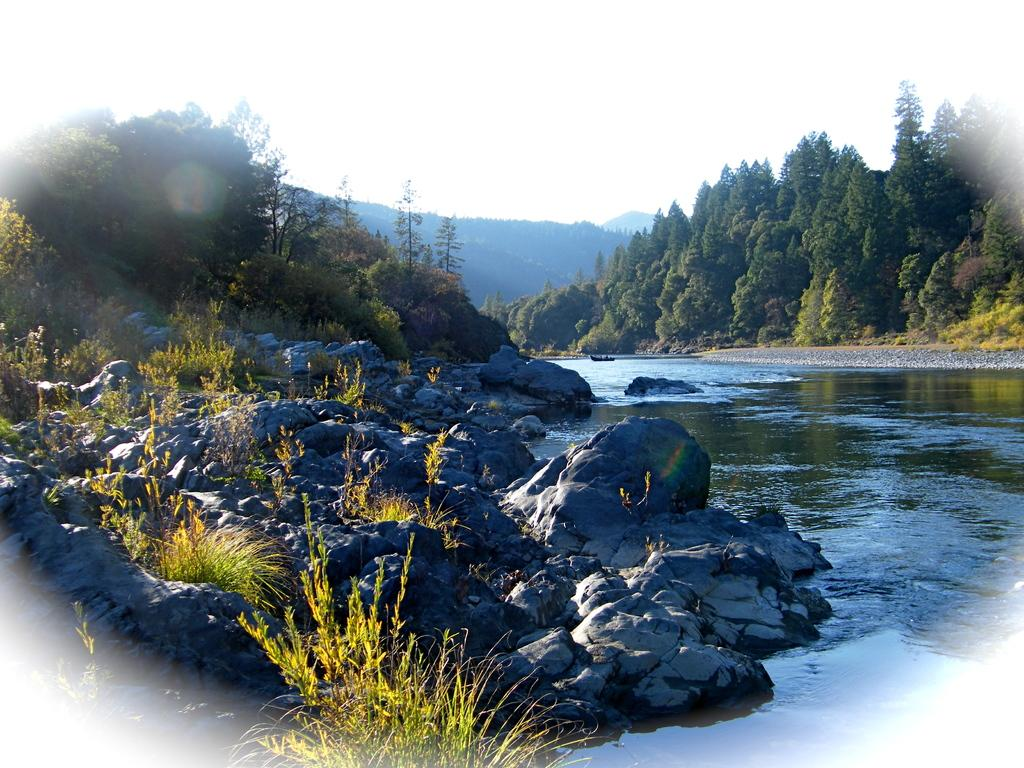What type of natural elements can be seen in the image? There are rocks, water, and trees visible in the image. What is the condition of the sky in the image? Clouds are visible in the sky in the image. Can you see a flower being twisted by the mom in the image? There is no flower or mom present in the image. 